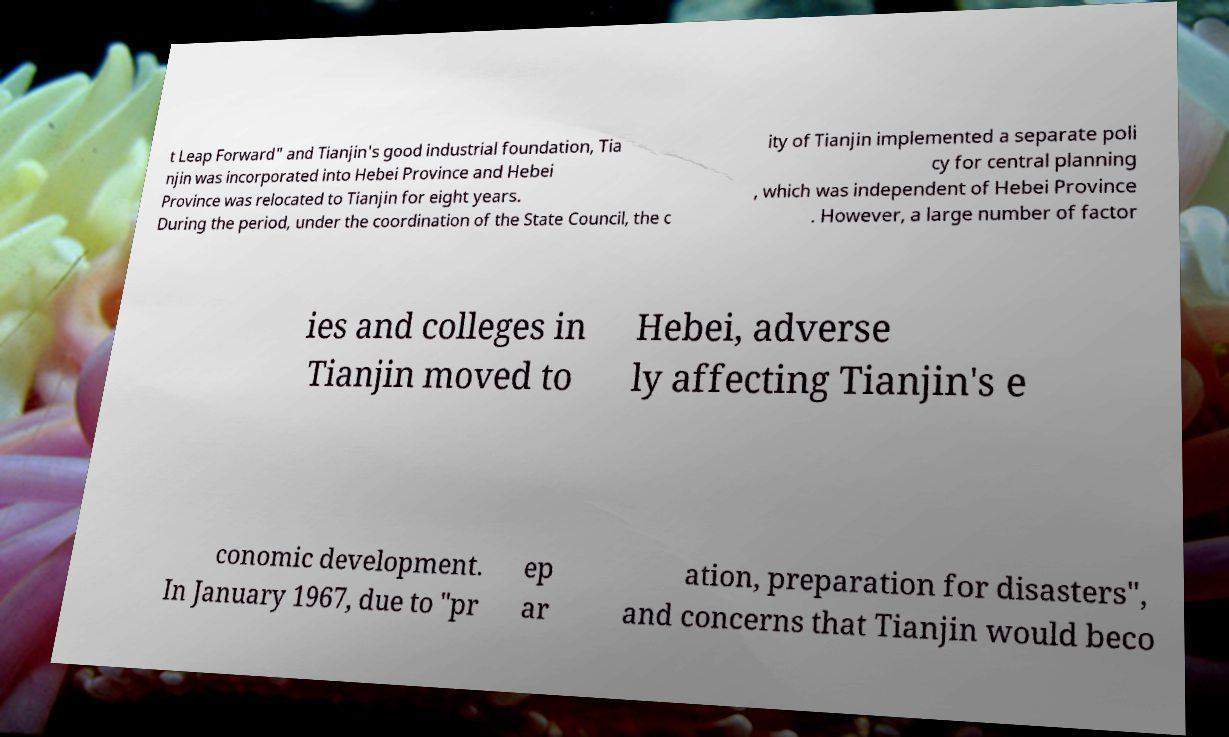Could you extract and type out the text from this image? t Leap Forward" and Tianjin's good industrial foundation, Tia njin was incorporated into Hebei Province and Hebei Province was relocated to Tianjin for eight years. During the period, under the coordination of the State Council, the c ity of Tianjin implemented a separate poli cy for central planning , which was independent of Hebei Province . However, a large number of factor ies and colleges in Tianjin moved to Hebei, adverse ly affecting Tianjin's e conomic development. In January 1967, due to "pr ep ar ation, preparation for disasters", and concerns that Tianjin would beco 